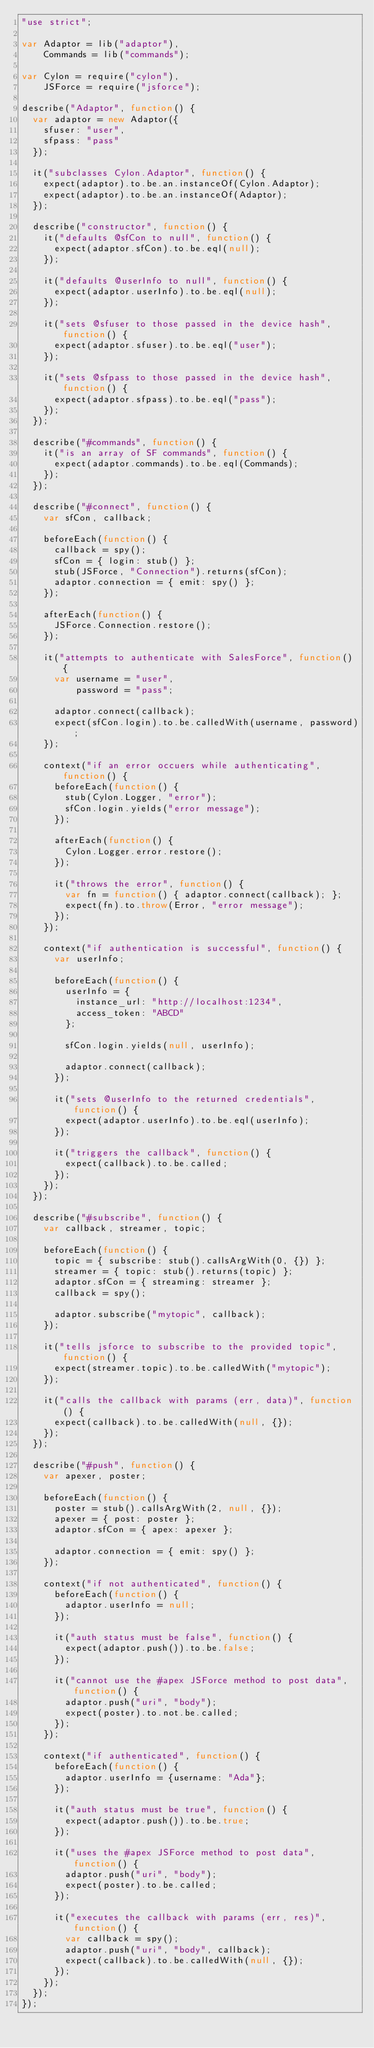<code> <loc_0><loc_0><loc_500><loc_500><_JavaScript_>"use strict";

var Adaptor = lib("adaptor"),
    Commands = lib("commands");

var Cylon = require("cylon"),
    JSForce = require("jsforce");

describe("Adaptor", function() {
  var adaptor = new Adaptor({
    sfuser: "user",
    sfpass: "pass"
  });

  it("subclasses Cylon.Adaptor", function() {
    expect(adaptor).to.be.an.instanceOf(Cylon.Adaptor);
    expect(adaptor).to.be.an.instanceOf(Adaptor);
  });

  describe("constructor", function() {
    it("defaults @sfCon to null", function() {
      expect(adaptor.sfCon).to.be.eql(null);
    });

    it("defaults @userInfo to null", function() {
      expect(adaptor.userInfo).to.be.eql(null);
    });

    it("sets @sfuser to those passed in the device hash", function() {
      expect(adaptor.sfuser).to.be.eql("user");
    });

    it("sets @sfpass to those passed in the device hash", function() {
      expect(adaptor.sfpass).to.be.eql("pass");
    });
  });

  describe("#commands", function() {
    it("is an array of SF commands", function() {
      expect(adaptor.commands).to.be.eql(Commands);
    });
  });

  describe("#connect", function() {
    var sfCon, callback;

    beforeEach(function() {
      callback = spy();
      sfCon = { login: stub() };
      stub(JSForce, "Connection").returns(sfCon);
      adaptor.connection = { emit: spy() };
    });

    afterEach(function() {
      JSForce.Connection.restore();
    });

    it("attempts to authenticate with SalesForce", function() {
      var username = "user",
          password = "pass";

      adaptor.connect(callback);
      expect(sfCon.login).to.be.calledWith(username, password);
    });

    context("if an error occuers while authenticating", function() {
      beforeEach(function() {
        stub(Cylon.Logger, "error");
        sfCon.login.yields("error message");
      });

      afterEach(function() {
        Cylon.Logger.error.restore();
      });

      it("throws the error", function() {
        var fn = function() { adaptor.connect(callback); };
        expect(fn).to.throw(Error, "error message");
      });
    });

    context("if authentication is successful", function() {
      var userInfo;

      beforeEach(function() {
        userInfo = {
          instance_url: "http://localhost:1234",
          access_token: "ABCD"
        };

        sfCon.login.yields(null, userInfo);

        adaptor.connect(callback);
      });

      it("sets @userInfo to the returned credentials", function() {
        expect(adaptor.userInfo).to.be.eql(userInfo);
      });

      it("triggers the callback", function() {
        expect(callback).to.be.called;
      });
    });
  });

  describe("#subscribe", function() {
    var callback, streamer, topic;

    beforeEach(function() {
      topic = { subscribe: stub().callsArgWith(0, {}) };
      streamer = { topic: stub().returns(topic) };
      adaptor.sfCon = { streaming: streamer };
      callback = spy();

      adaptor.subscribe("mytopic", callback);
    });

    it("tells jsforce to subscribe to the provided topic", function() {
      expect(streamer.topic).to.be.calledWith("mytopic");
    });

    it("calls the callback with params (err, data)", function() {
      expect(callback).to.be.calledWith(null, {});
    });
  });

  describe("#push", function() {
    var apexer, poster;

    beforeEach(function() {
      poster = stub().callsArgWith(2, null, {});
      apexer = { post: poster };
      adaptor.sfCon = { apex: apexer };

      adaptor.connection = { emit: spy() };
    });

    context("if not authenticated", function() {
      beforeEach(function() {
        adaptor.userInfo = null;
      });

      it("auth status must be false", function() {
        expect(adaptor.push()).to.be.false;
      });

      it("cannot use the #apex JSForce method to post data", function() {
        adaptor.push("uri", "body");
        expect(poster).to.not.be.called;
      });
    });

    context("if authenticated", function() {
      beforeEach(function() {
        adaptor.userInfo = {username: "Ada"};
      });

      it("auth status must be true", function() {
        expect(adaptor.push()).to.be.true;
      });

      it("uses the #apex JSForce method to post data", function() {
        adaptor.push("uri", "body");
        expect(poster).to.be.called;
      });

      it("executes the callback with params (err, res)", function() {
        var callback = spy();
        adaptor.push("uri", "body", callback);
        expect(callback).to.be.calledWith(null, {});
      });
    });
  });
});
</code> 